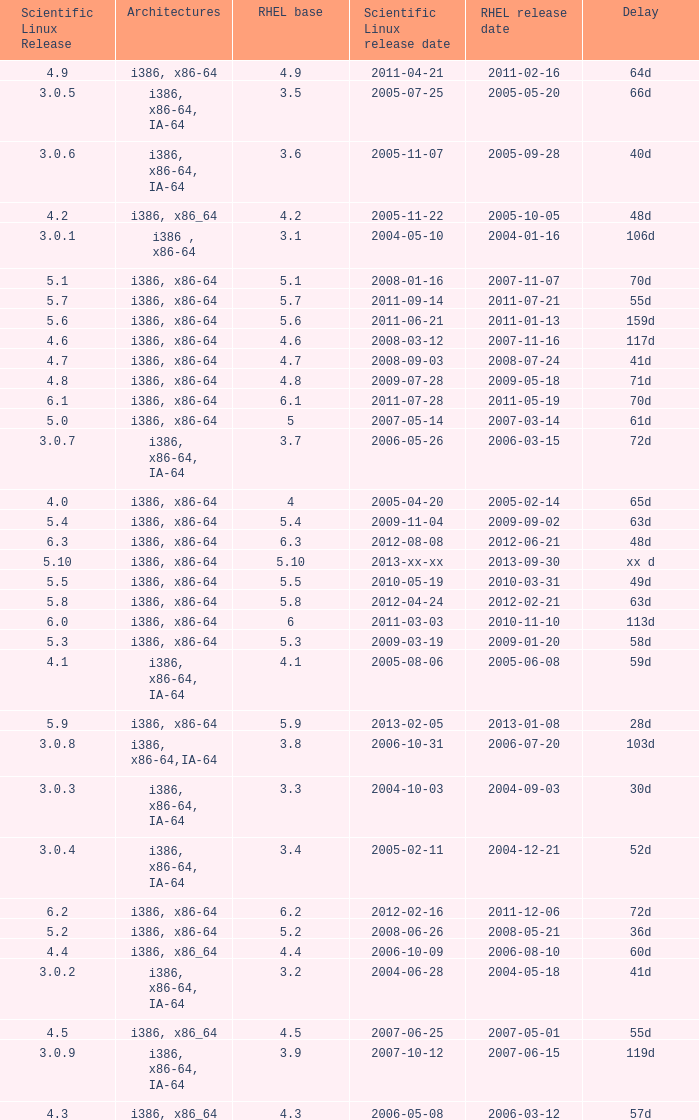What is the scientific linux edition when the deferral period is 28 days? 5.9. 